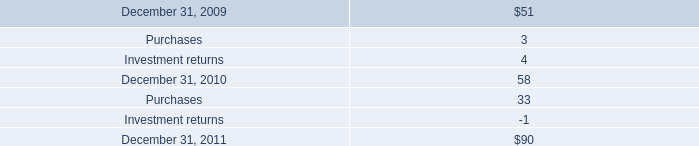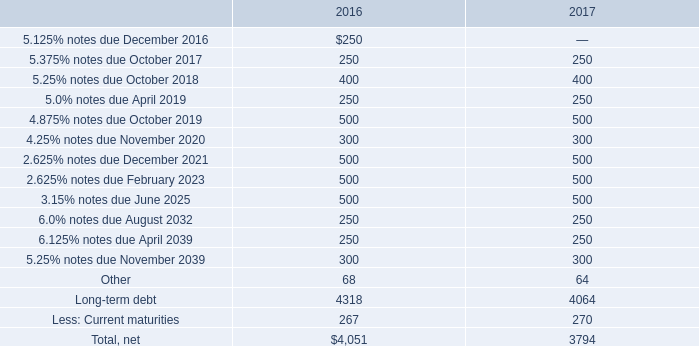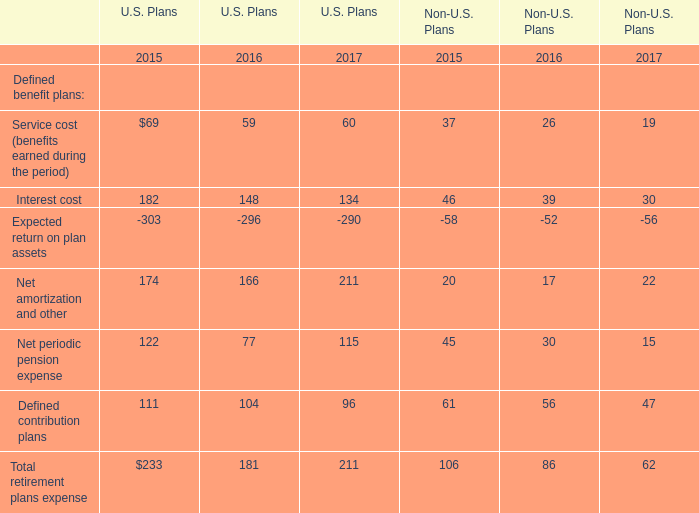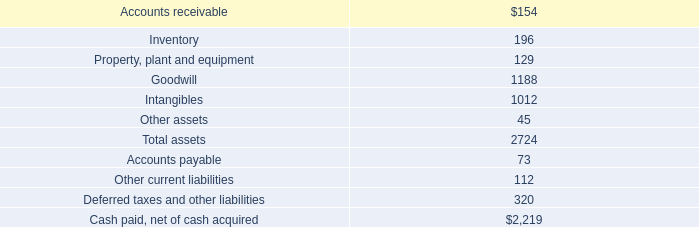What is the percentage of3.15% notes due June 2025 in relation to the total in 2016 ? 
Computations: (500 / 4051)
Answer: 0.12343. 